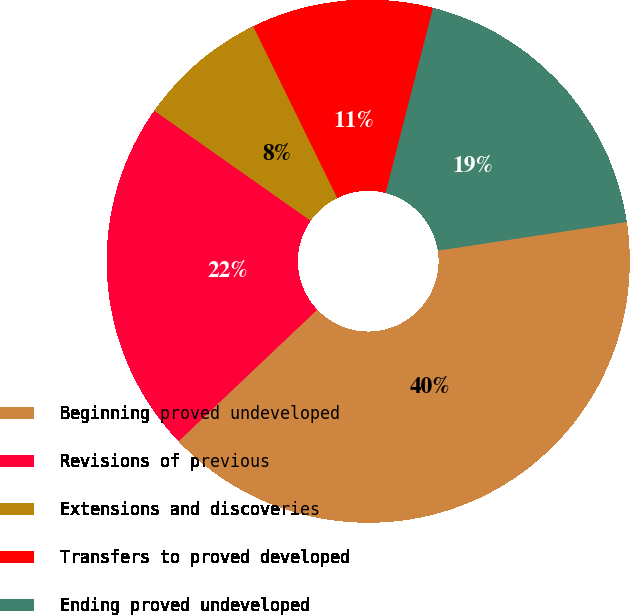<chart> <loc_0><loc_0><loc_500><loc_500><pie_chart><fcel>Beginning proved undeveloped<fcel>Revisions of previous<fcel>Extensions and discoveries<fcel>Transfers to proved developed<fcel>Ending proved undeveloped<nl><fcel>40.32%<fcel>21.84%<fcel>8.0%<fcel>11.23%<fcel>18.61%<nl></chart> 